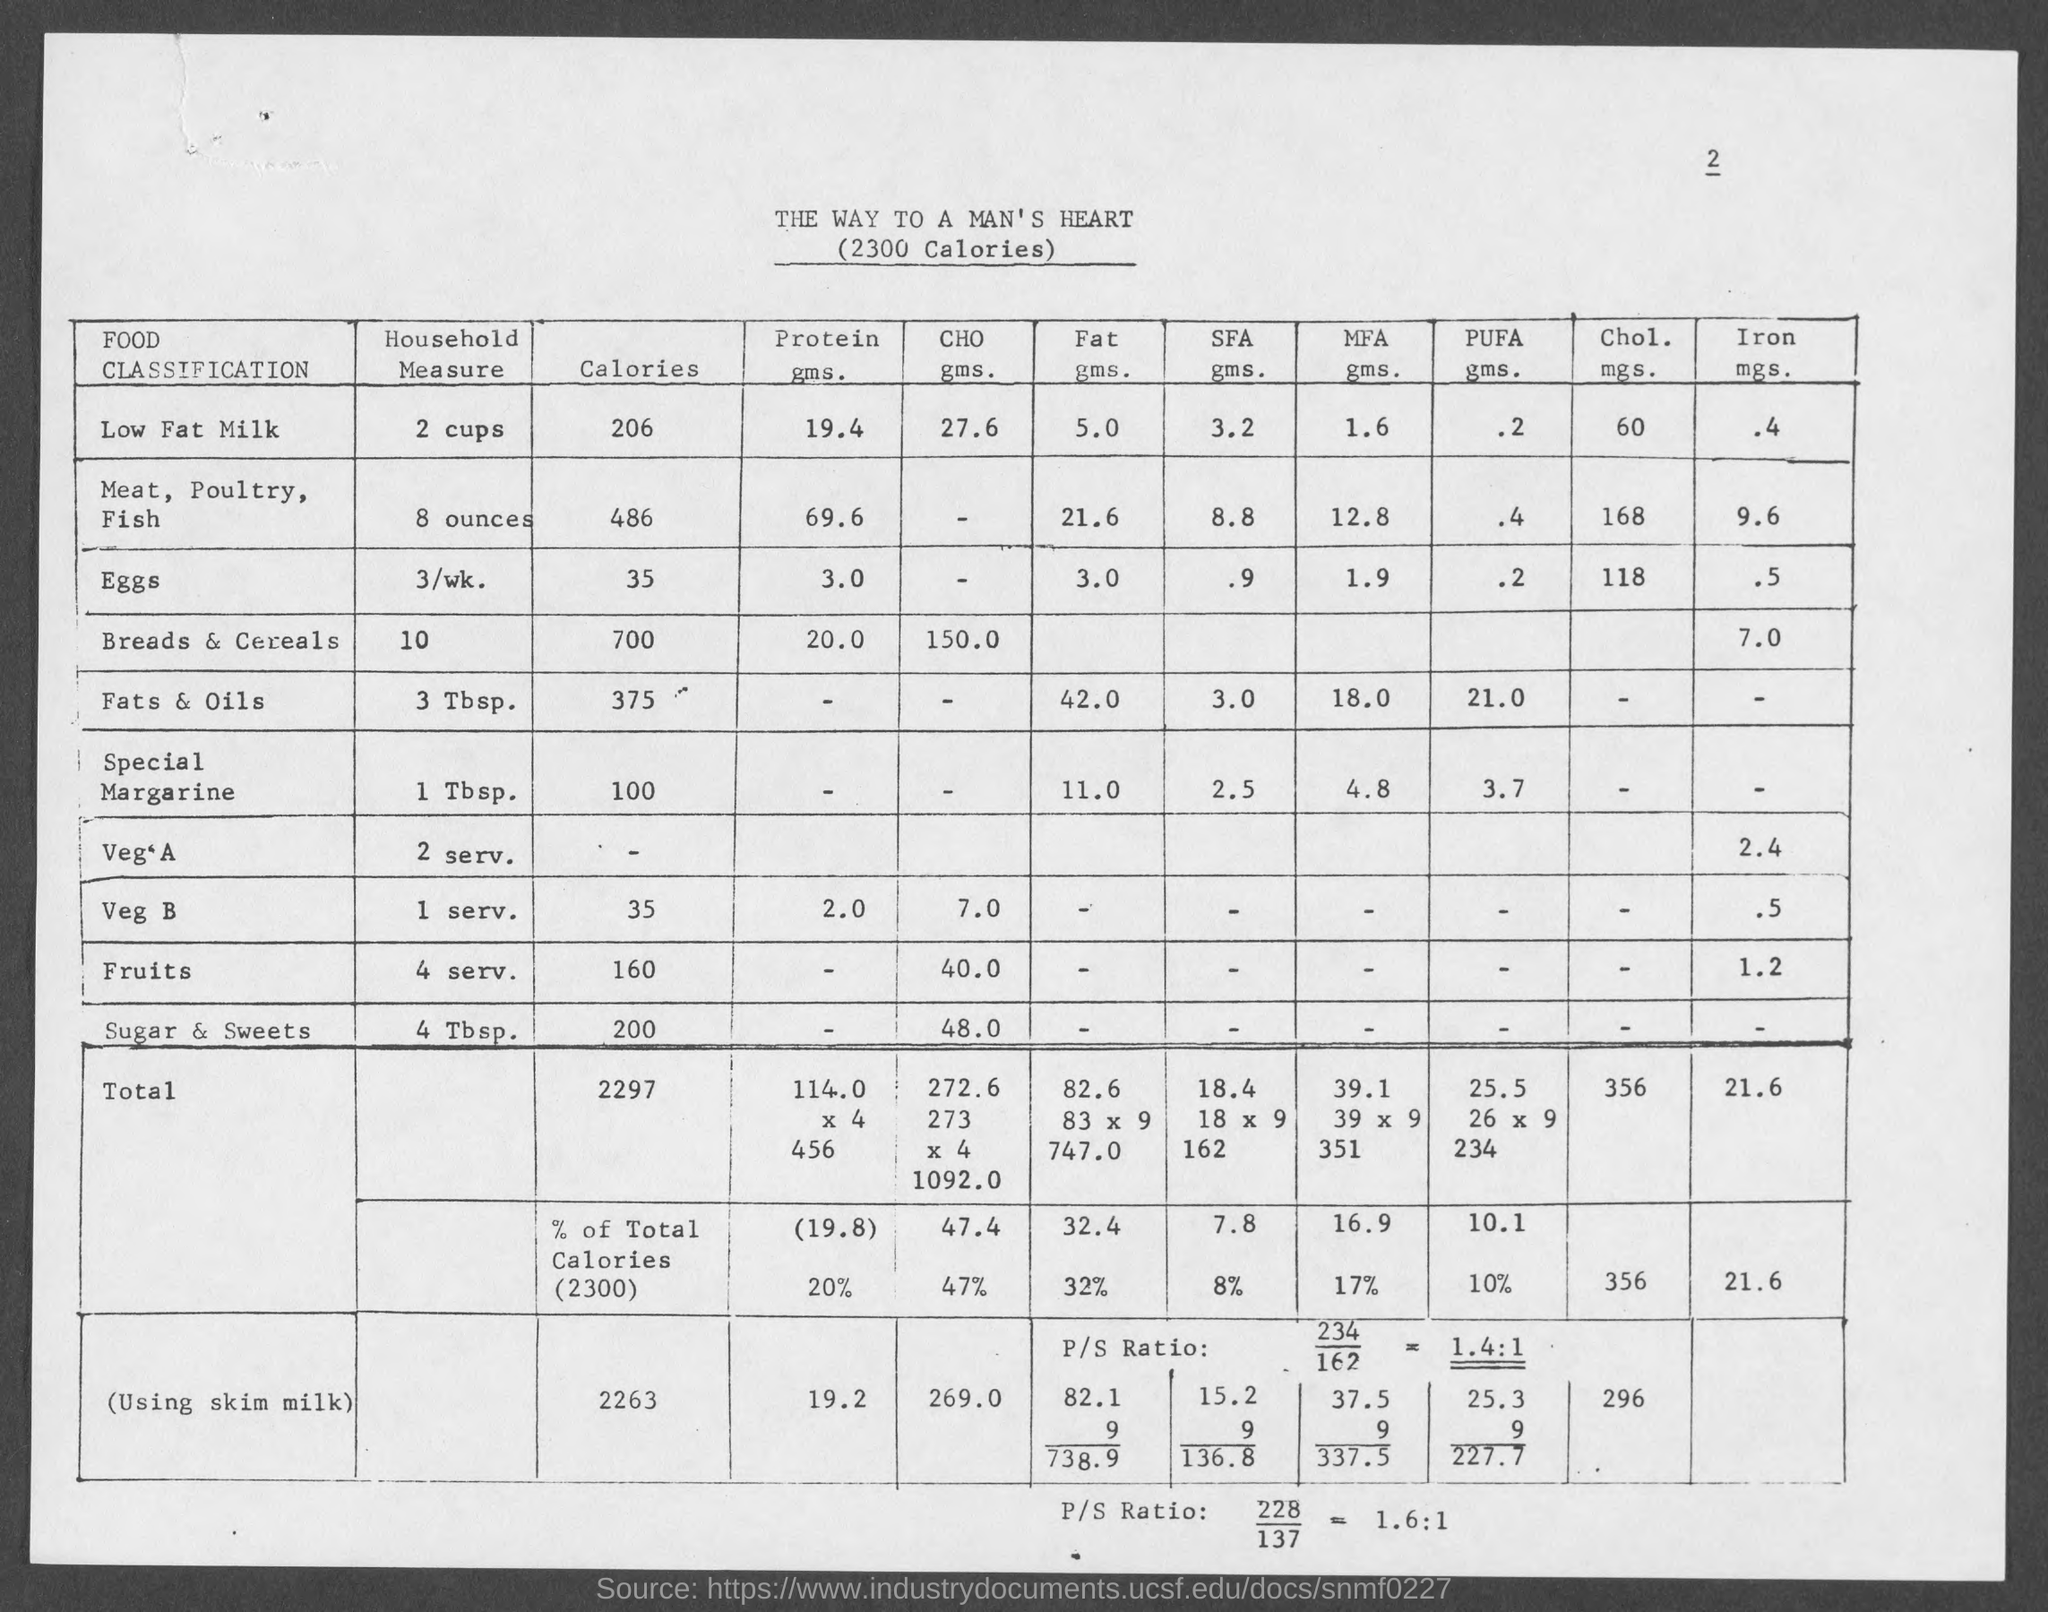Point out several critical features in this image. There is 69.6 grams of protein in 8 ounces of Meat, Poultry, Fish. There is 60 milligrams of cholesterol in 2 cups of low-fat milk. There is 19.4 grams of protein in 2 cups of low-fat milk. Eight ounces of meat, poultry, or fish contains approximately 21.6 grams of fat. There is 9.6 grams of iron in 8 ounces of Meat, Poultry, and Fish. 